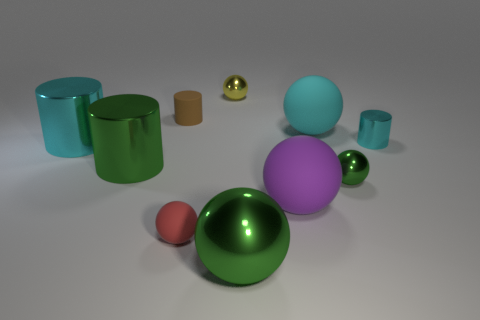There is a cyan metallic cylinder in front of the shiny cylinder right of the purple sphere that is to the right of the big green shiny sphere; how big is it?
Offer a very short reply. Large. How many other things are there of the same color as the small metallic cylinder?
Your answer should be very brief. 2. There is a large shiny sphere that is in front of the big cyan metallic object; does it have the same color as the small matte cylinder?
Provide a succinct answer. No. How many things are large cylinders or brown rubber cylinders?
Give a very brief answer. 3. There is a large shiny thing in front of the tiny red rubber object; what is its color?
Ensure brevity in your answer.  Green. Is the number of big cyan shiny cylinders left of the red thing less than the number of big things?
Keep it short and to the point. Yes. The cylinder that is the same color as the large metal sphere is what size?
Your answer should be very brief. Large. Is there anything else that has the same size as the red matte sphere?
Offer a terse response. Yes. Is the cyan ball made of the same material as the large green ball?
Keep it short and to the point. No. What number of things are either cylinders to the right of the green shiny cylinder or matte objects that are on the right side of the yellow object?
Provide a short and direct response. 4. 